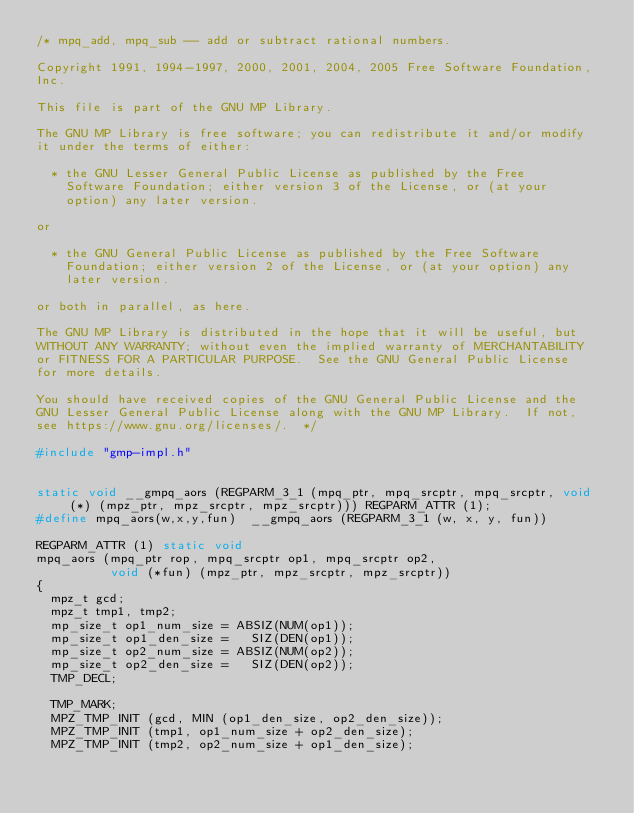<code> <loc_0><loc_0><loc_500><loc_500><_C_>/* mpq_add, mpq_sub -- add or subtract rational numbers.

Copyright 1991, 1994-1997, 2000, 2001, 2004, 2005 Free Software Foundation,
Inc.

This file is part of the GNU MP Library.

The GNU MP Library is free software; you can redistribute it and/or modify
it under the terms of either:

  * the GNU Lesser General Public License as published by the Free
    Software Foundation; either version 3 of the License, or (at your
    option) any later version.

or

  * the GNU General Public License as published by the Free Software
    Foundation; either version 2 of the License, or (at your option) any
    later version.

or both in parallel, as here.

The GNU MP Library is distributed in the hope that it will be useful, but
WITHOUT ANY WARRANTY; without even the implied warranty of MERCHANTABILITY
or FITNESS FOR A PARTICULAR PURPOSE.  See the GNU General Public License
for more details.

You should have received copies of the GNU General Public License and the
GNU Lesser General Public License along with the GNU MP Library.  If not,
see https://www.gnu.org/licenses/.  */

#include "gmp-impl.h"


static void __gmpq_aors (REGPARM_3_1 (mpq_ptr, mpq_srcptr, mpq_srcptr, void (*) (mpz_ptr, mpz_srcptr, mpz_srcptr))) REGPARM_ATTR (1);
#define mpq_aors(w,x,y,fun)  __gmpq_aors (REGPARM_3_1 (w, x, y, fun))

REGPARM_ATTR (1) static void
mpq_aors (mpq_ptr rop, mpq_srcptr op1, mpq_srcptr op2,
          void (*fun) (mpz_ptr, mpz_srcptr, mpz_srcptr))
{
  mpz_t gcd;
  mpz_t tmp1, tmp2;
  mp_size_t op1_num_size = ABSIZ(NUM(op1));
  mp_size_t op1_den_size =   SIZ(DEN(op1));
  mp_size_t op2_num_size = ABSIZ(NUM(op2));
  mp_size_t op2_den_size =   SIZ(DEN(op2));
  TMP_DECL;

  TMP_MARK;
  MPZ_TMP_INIT (gcd, MIN (op1_den_size, op2_den_size));
  MPZ_TMP_INIT (tmp1, op1_num_size + op2_den_size);
  MPZ_TMP_INIT (tmp2, op2_num_size + op1_den_size);
</code> 